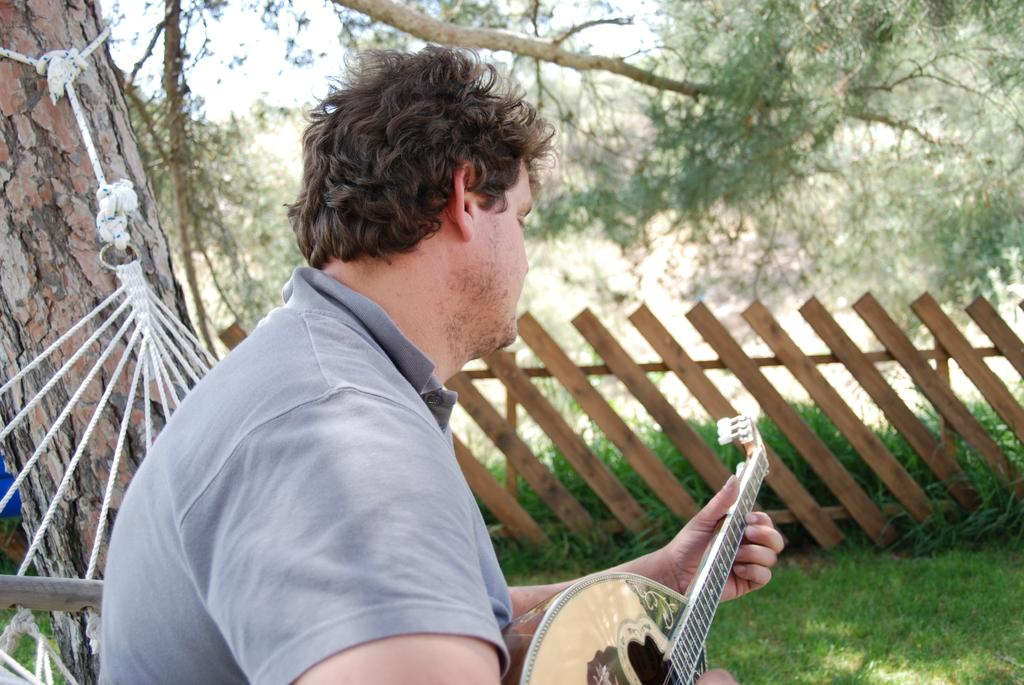What is the man in the image doing? The man is playing a guitar in the image. What type of surface is the man standing on? There is grass in the image, so the man is likely standing on grass. What can be seen in the background of the image? There are trees and the sky visible in the background of the image. Are there any structures or objects in the image? Yes, there is a fence in the image. How many chickens are visible in the image? There are no chickens present in the image. What is the man's level of wealth based on the image? The image does not provide any information about the man's wealth. Is there a hill visible in the image? There is no hill present in the image. 